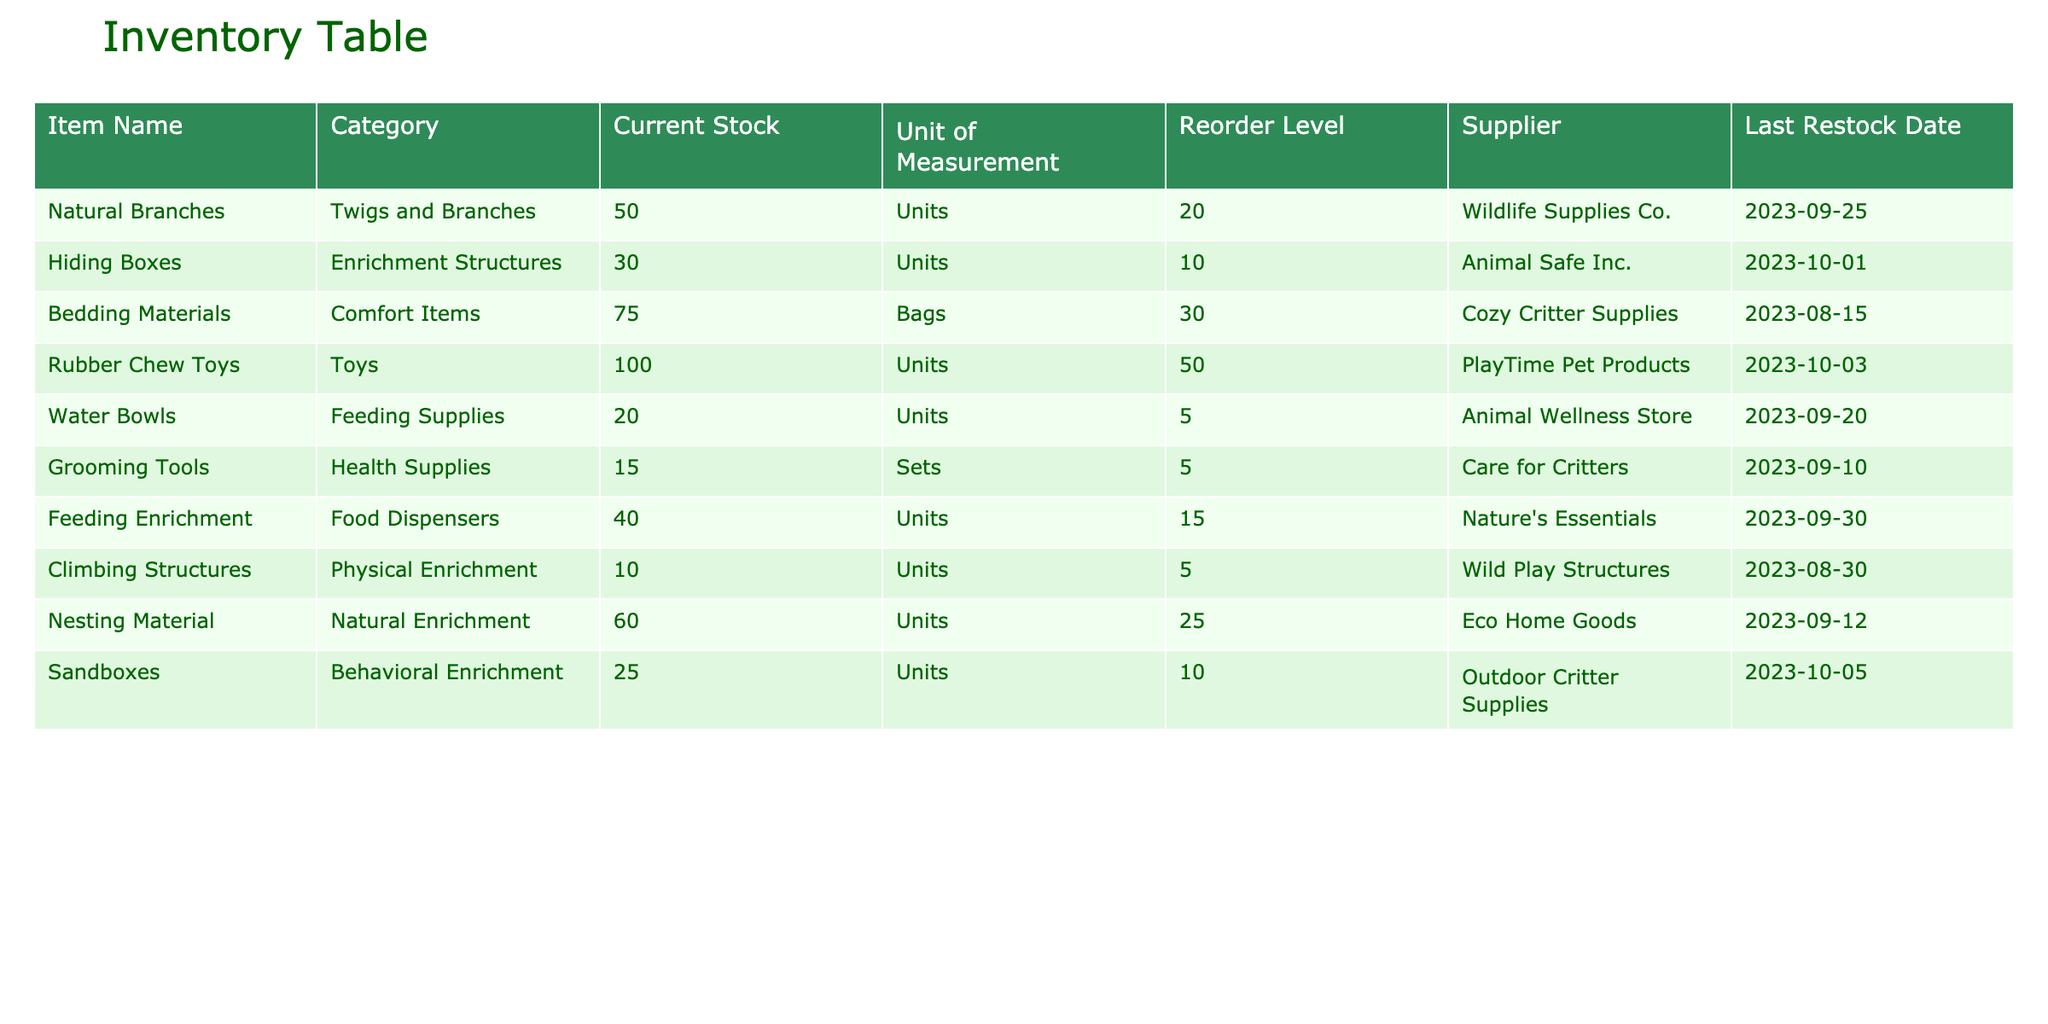What is the current stock level of hiding boxes? The table displays the "Current Stock" column, and for the item "Hiding Boxes," it indicates a stock level of 30 units.
Answer: 30 Which supplier provides the grooming tools? By examining the "Supplier" column for "Grooming Tools," we see that it is supplied by "Care for Critters."
Answer: Care for Critters What is the total current stock of toys and comfort items? To find the total stock, we look at the current stock for "Rubber Chew Toys" (100 units) and "Bedding Materials" (75 bags). Adding these gives 100 + 75 = 175.
Answer: 175 Are there more units of climbing structures or nesting material in stock? The current stock shows 10 units for "Climbing Structures" and 60 units for "Nesting Material." Since 60 is greater than 10, we conclude that there are more units of nesting material.
Answer: Yes What percentage of water bowls reaches the reorder level? The reorder level for water bowls is 5 units, and the current stock is 20 units. To find the percentage, we calculate (20/5) * 100 = 400%. So, it's 400% of the reorder level.
Answer: 400% What is the average current stock level of enrichment structures and behavioral enrichment items? The stock level for "Hiding Boxes" (30 units) falls under enrichment structures, and "Sandboxes" (25 units) falls under behavioral enrichment. To find the average: (30 + 25) / 2 = 27.5.
Answer: 27.5 Which item has the highest stock level among all categories? Looking through the "Current Stock" column, "Rubber Chew Toys" has the highest stock at 100 units compared to other items.
Answer: Rubber Chew Toys Is the last restock date for bedding materials before or after October 1, 2023? The last restock date for "Bedding Materials" is August 15, 2023. Since August comes before October, the restock date is before October 1.
Answer: Before What is the difference in stock level between the highest and lowest stocked item? The highest stock level is for "Rubber Chew Toys" (100), and the lowest is "Climbing Structures" (10). The difference is 100 - 10 = 90.
Answer: 90 